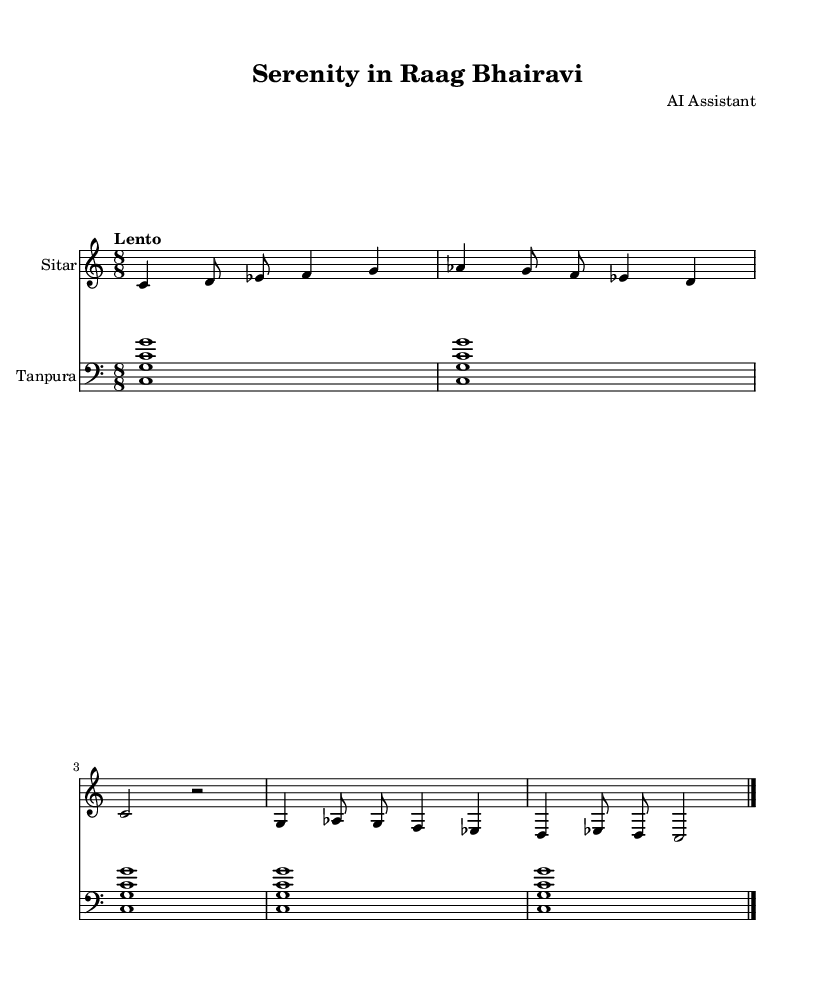What is the key signature of this music? The key signature is C major, which has no sharps or flats.
Answer: C major What is the time signature of the piece? The time signature is indicated by the “8/8” at the beginning of the score, which means there are eight beats in each measure, and the eighth note gets the beat.
Answer: 8/8 What is the indicated tempo of the piece? The tempo is marked "Lento," which dictates a slow speed, but does not provide a numerical value.
Answer: Lento How many measures are there in the Sitar part? By counting the segments separated by the vertical bar lines, we see that there are 5 measures in the Sitar part.
Answer: 5 What instruments are used in this composition? The score specifies two instruments: Sitar and Tanpura, which are both traditional instruments in Indian classical music.
Answer: Sitar and Tanpura Which musical note appears first in the Sitar staff? The first note is indicated at the beginning of the Sitar staff where the note C is placed.
Answer: C How does the Tanpura contribute to the overall texture of the piece? The Tanpura creates a drone by repeating the notes C and G, which enhances the harmonic support and grounding for the melodic lines played on the Sitar.
Answer: Drone 